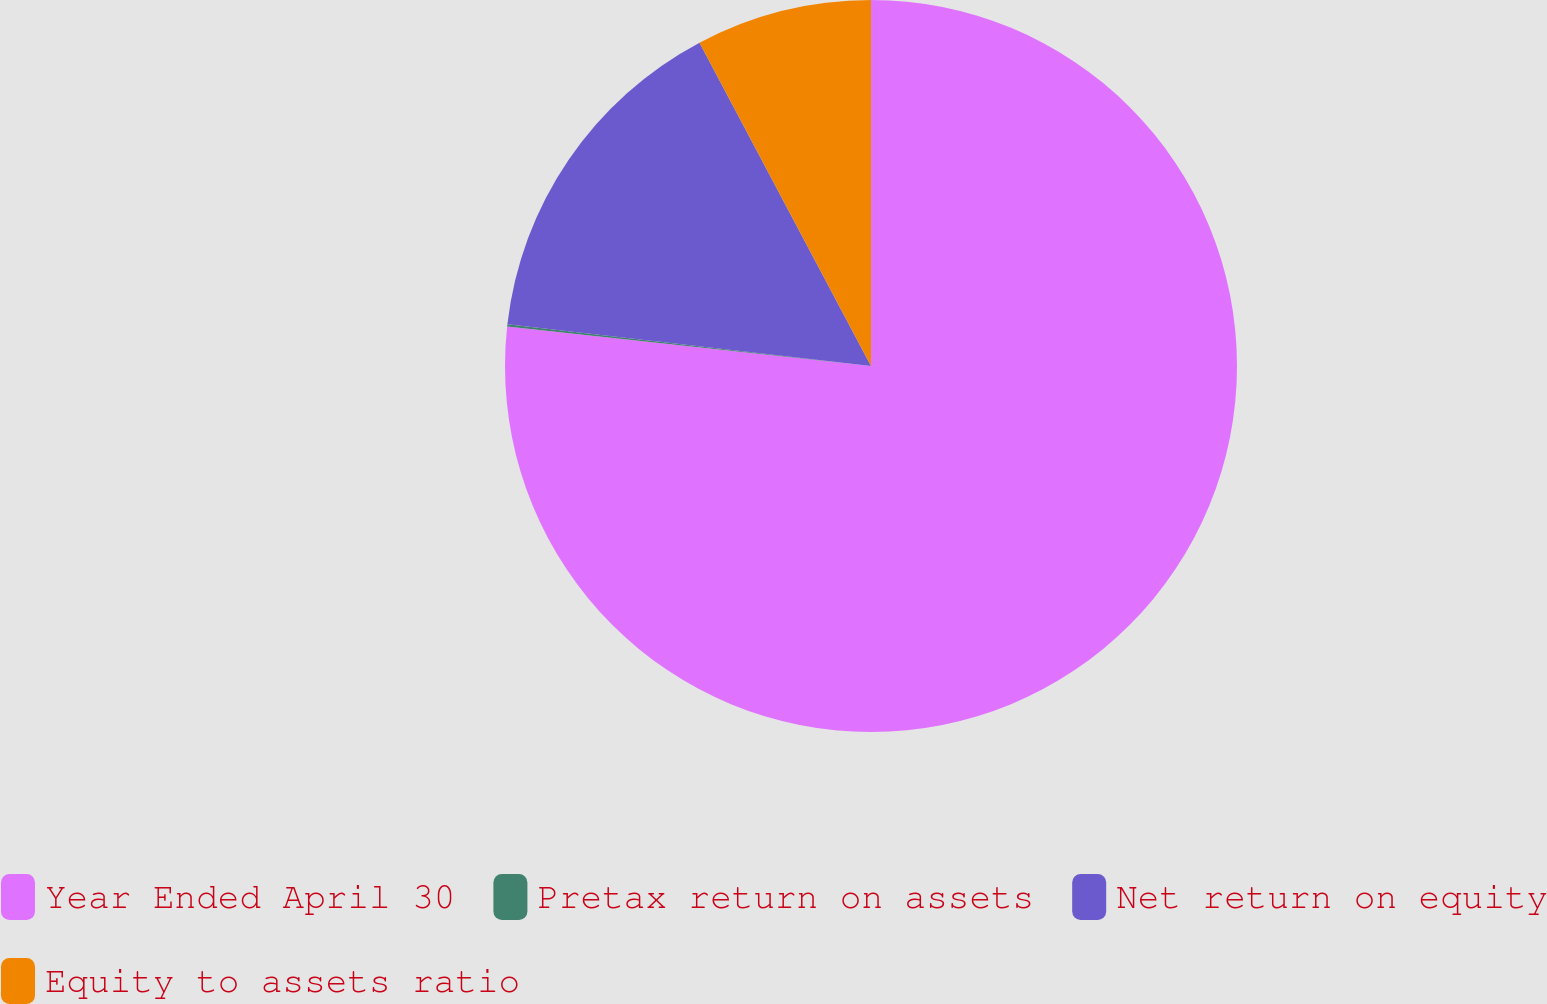<chart> <loc_0><loc_0><loc_500><loc_500><pie_chart><fcel>Year Ended April 30<fcel>Pretax return on assets<fcel>Net return on equity<fcel>Equity to assets ratio<nl><fcel>76.72%<fcel>0.1%<fcel>15.42%<fcel>7.76%<nl></chart> 